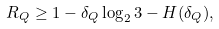<formula> <loc_0><loc_0><loc_500><loc_500>R _ { Q } \geq 1 - \delta _ { Q } \log _ { 2 } 3 - H ( \delta _ { Q } ) ,</formula> 